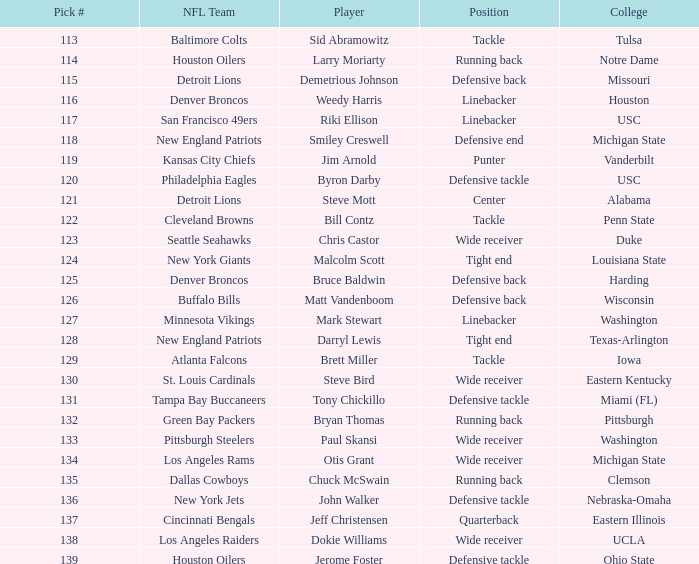The green bay packers picked which player? Bryan Thomas. 